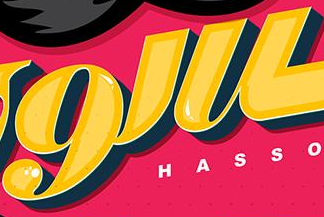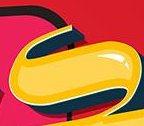Identify the words shown in these images in order, separated by a semicolon. 9'u; s 